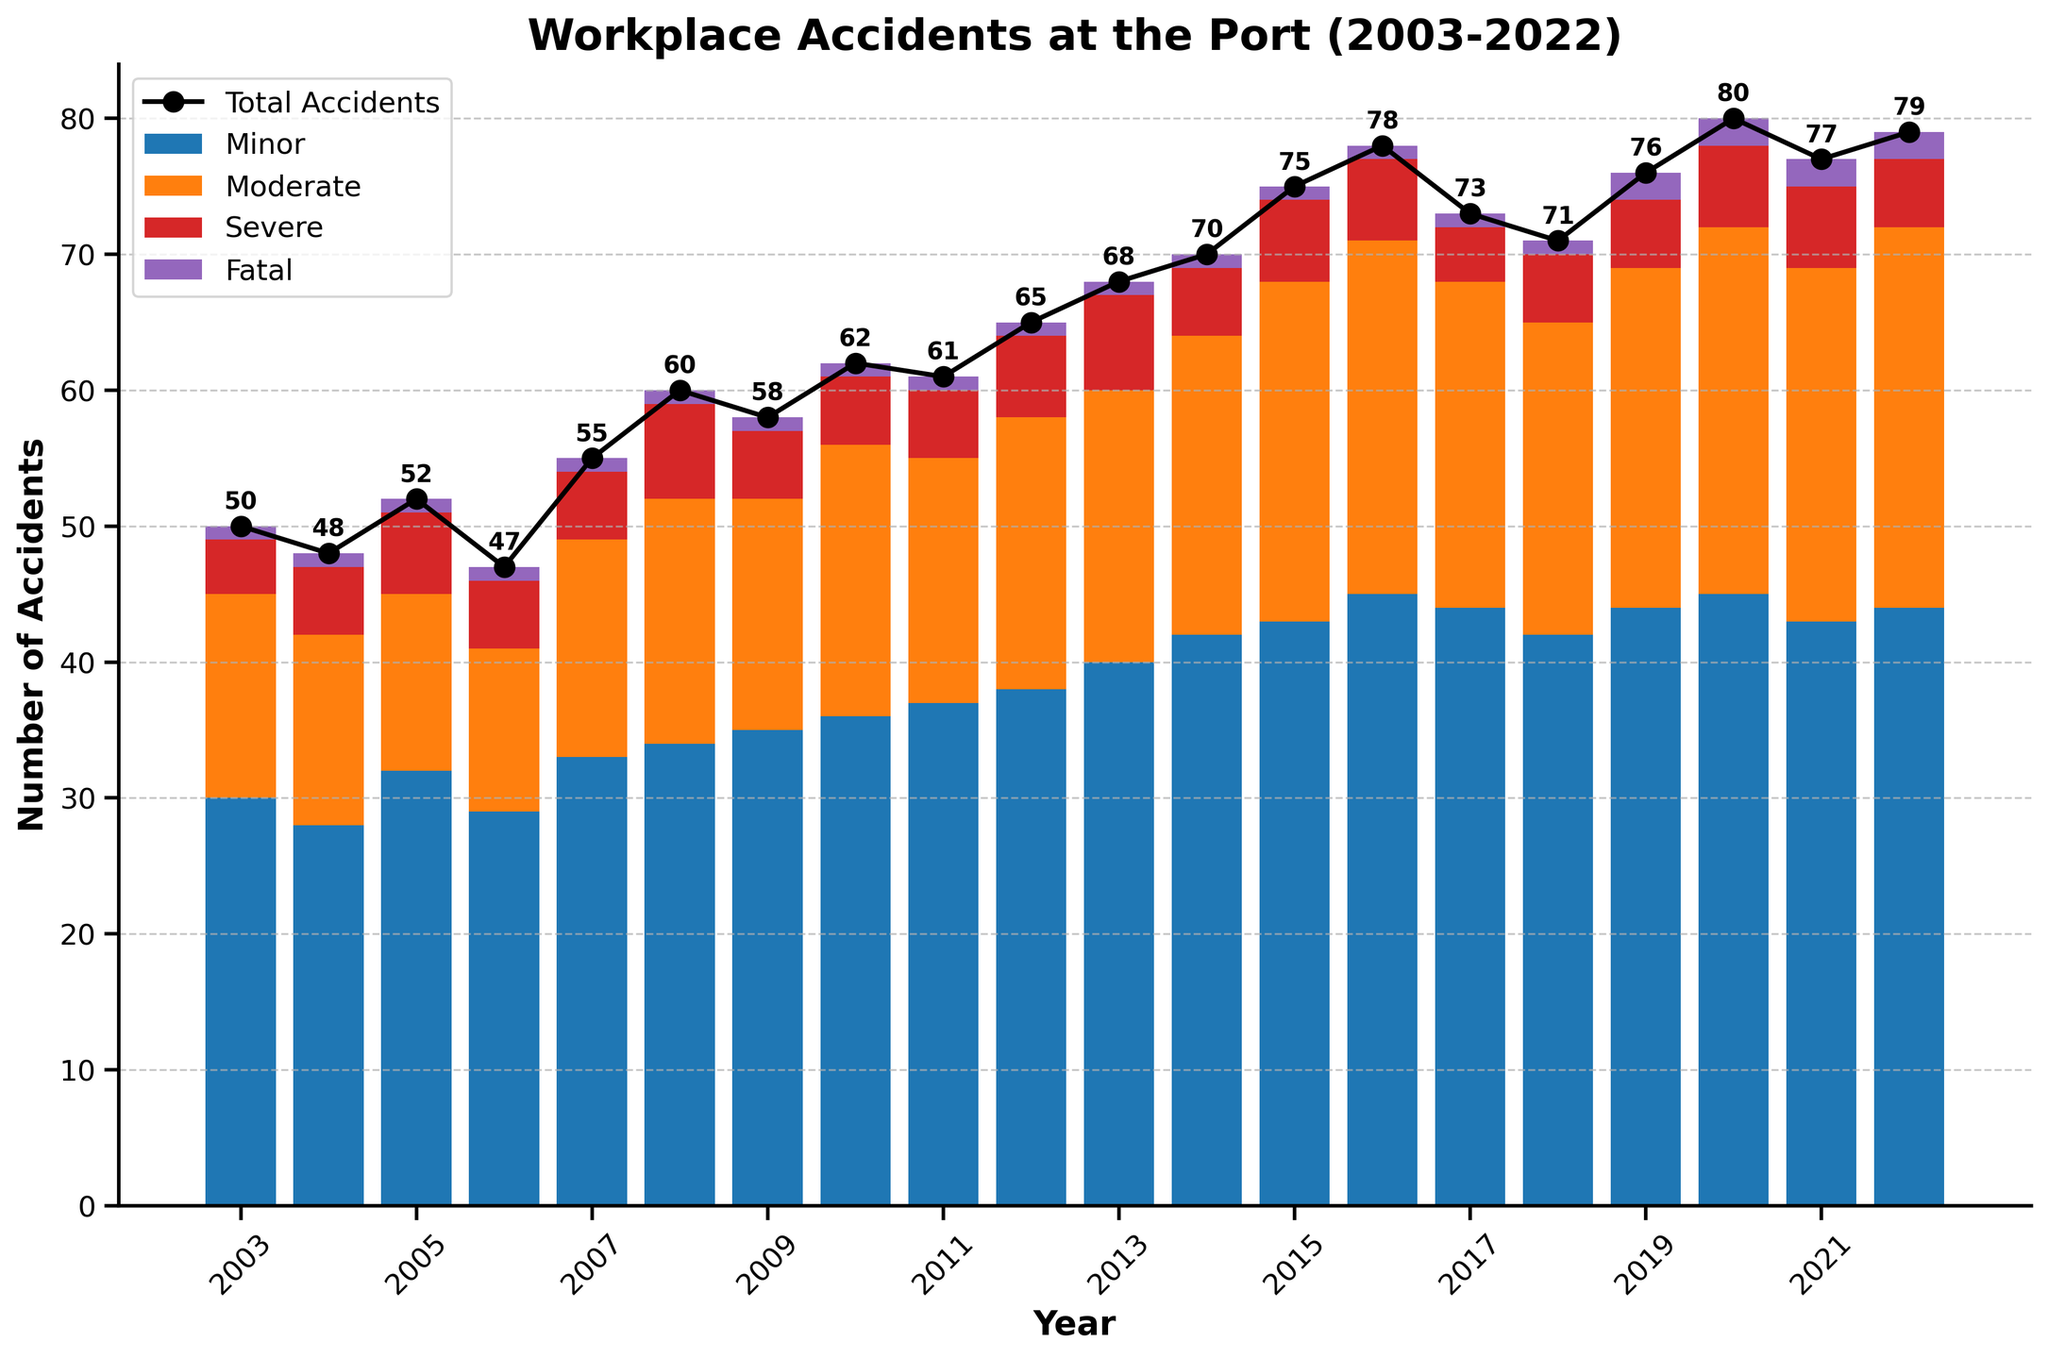What is the title of the figure? The title is usually found at the top of the plot and describes what the plot is about.
Answer: Workplace Accidents at the Port (2003-2022) How many total accidents occurred in 2020? Look for the data point labeled "2020" on the x-axis and check the corresponding "Total Accidents" value.
Answer: 80 Which year had the highest number of workplace accidents? Compare the "Total Accidents" values by examining the line plot across all years.
Answer: 2020 What is the trend in the total number of accidents from 2003 to 2022? Observe the overall direction of the line plot representing total accidents over the given years.
Answer: Increasing How many minor accidents were reported in 2015? Locate the year 2015 on the x-axis and check the height of the minor accidents bar for that year.
Answer: 43 In which year did the number of moderate accidents surpass 20 for the first time? Examine the heights of the bars representing moderate accidents and identify the first year where it exceeds the 20 mark.
Answer: 2014 Compare the total number of severe accidents in 2010 and 2018. Which year had fewer severe accidents? Check the heights of the "Severe" accident bars for 2010 and 2018 and compare the values.
Answer: 2018 What is the average number of fatal accidents per year between 2003 and 2022? Sum up the number of fatal accidents for all years and divide by the total number of years (20).
Answer: 1.15 How does the proportion of minor accidents compare to total accidents in 2007? Calculate the ratio of minor accidents to the total accidents for the year 2007 (minor/total).
Answer: 60% What is the difference in the number of moderate accidents between 2013 and 2014? Subtract the number of moderate accidents in 2013 from that in 2014.
Answer: 2 